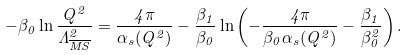Convert formula to latex. <formula><loc_0><loc_0><loc_500><loc_500>- \beta _ { 0 } \ln \frac { Q ^ { 2 } } { \Lambda _ { \overline { M S } } ^ { 2 } } = \frac { 4 \pi } { \alpha _ { s } ( Q ^ { 2 } ) } - \frac { \beta _ { 1 } } { \beta _ { 0 } } \ln \left ( - \frac { 4 \pi } { \beta _ { 0 } \alpha _ { s } ( Q ^ { 2 } ) } - \frac { \beta _ { 1 } } { \beta _ { 0 } ^ { 2 } } \right ) .</formula> 